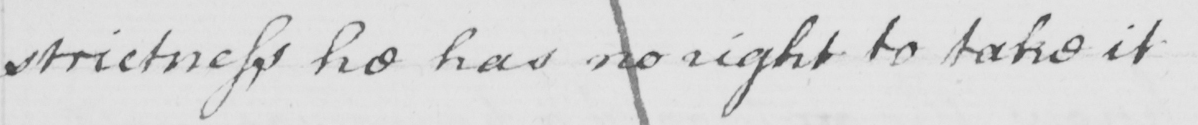Can you tell me what this handwritten text says? strictness he has no right to take it 